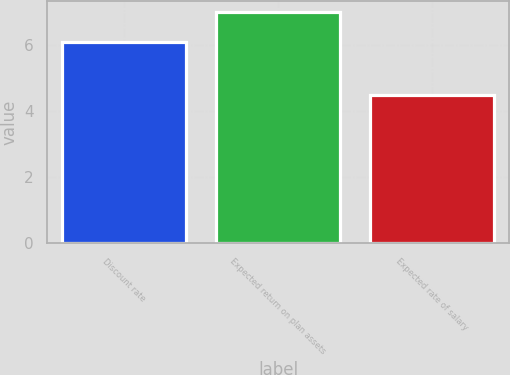Convert chart to OTSL. <chart><loc_0><loc_0><loc_500><loc_500><bar_chart><fcel>Discount rate<fcel>Expected return on plan assets<fcel>Expected rate of salary<nl><fcel>6.1<fcel>7<fcel>4.5<nl></chart> 